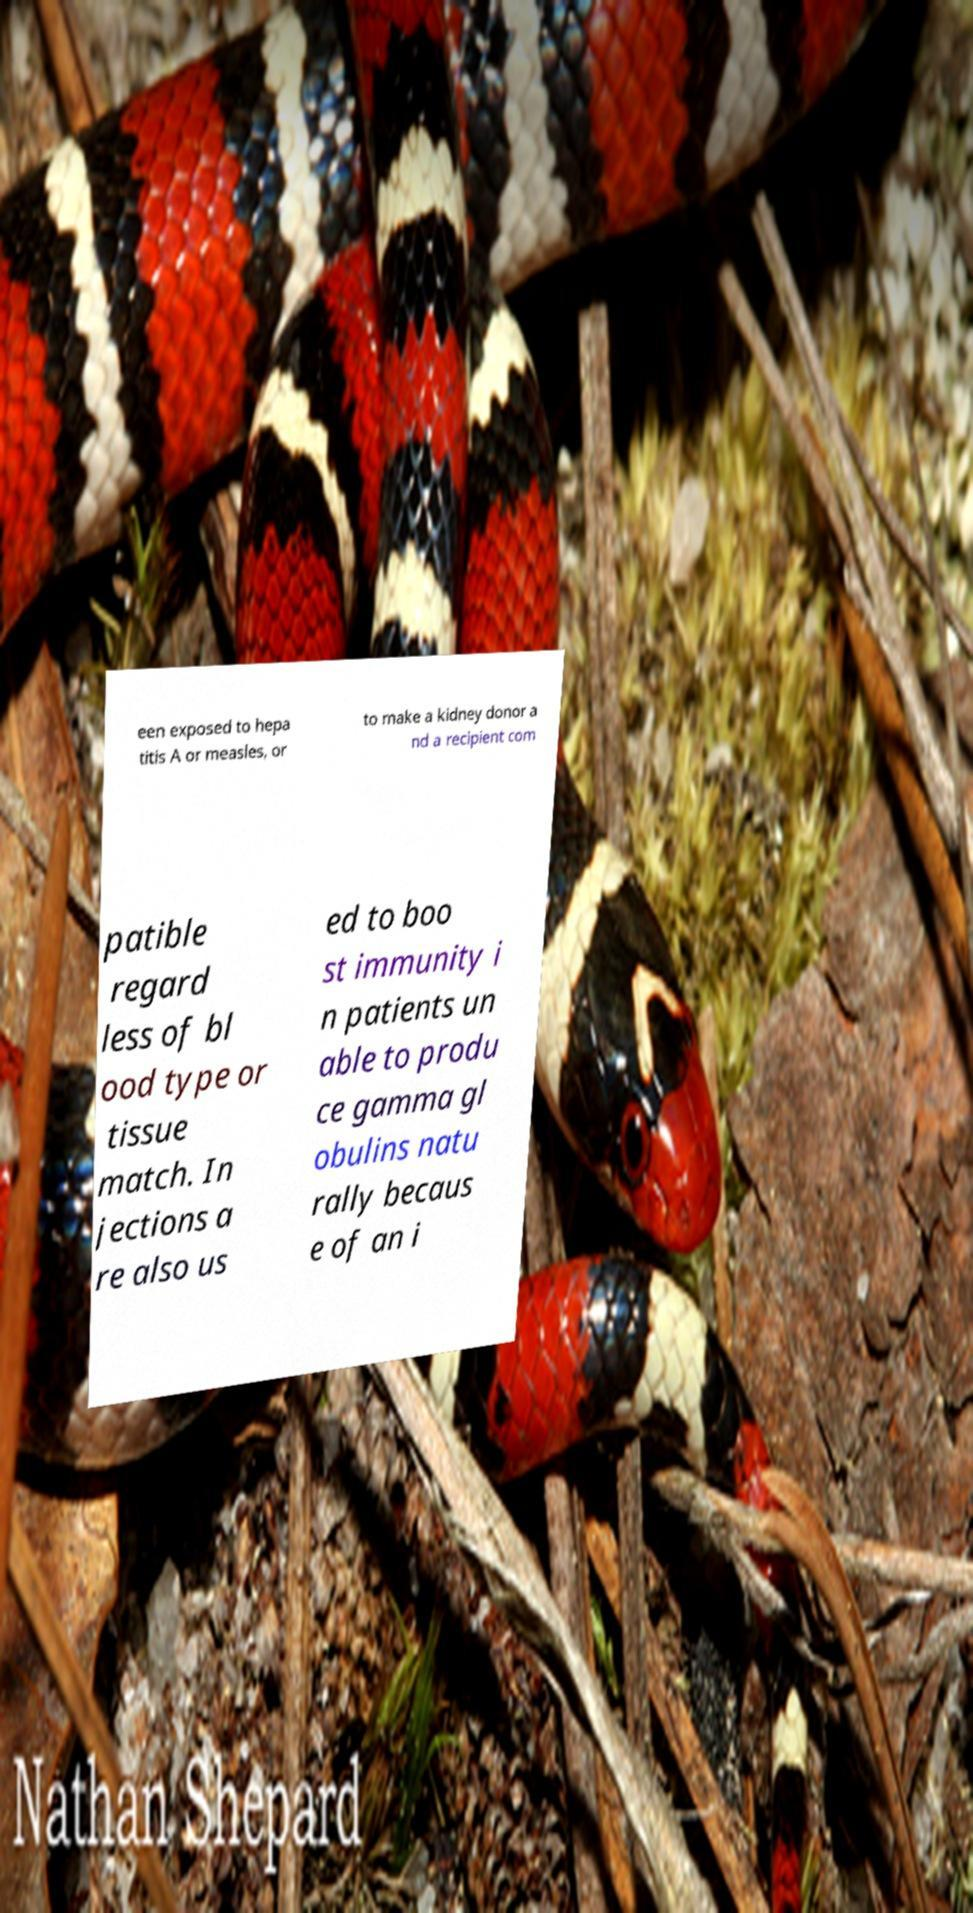Can you accurately transcribe the text from the provided image for me? een exposed to hepa titis A or measles, or to make a kidney donor a nd a recipient com patible regard less of bl ood type or tissue match. In jections a re also us ed to boo st immunity i n patients un able to produ ce gamma gl obulins natu rally becaus e of an i 